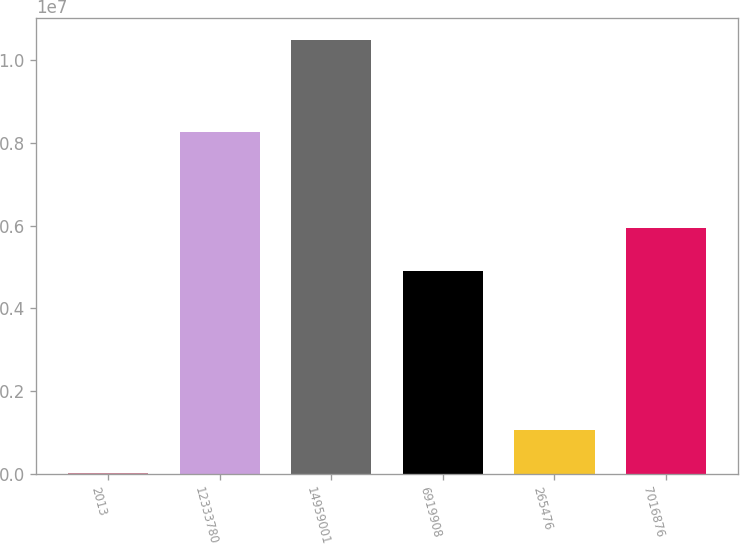Convert chart. <chart><loc_0><loc_0><loc_500><loc_500><bar_chart><fcel>2013<fcel>12333780<fcel>14959001<fcel>6919908<fcel>265476<fcel>7016876<nl><fcel>2009<fcel>8.2571e+06<fcel>1.04884e+07<fcel>4.89269e+06<fcel>1.05065e+06<fcel>5.94133e+06<nl></chart> 